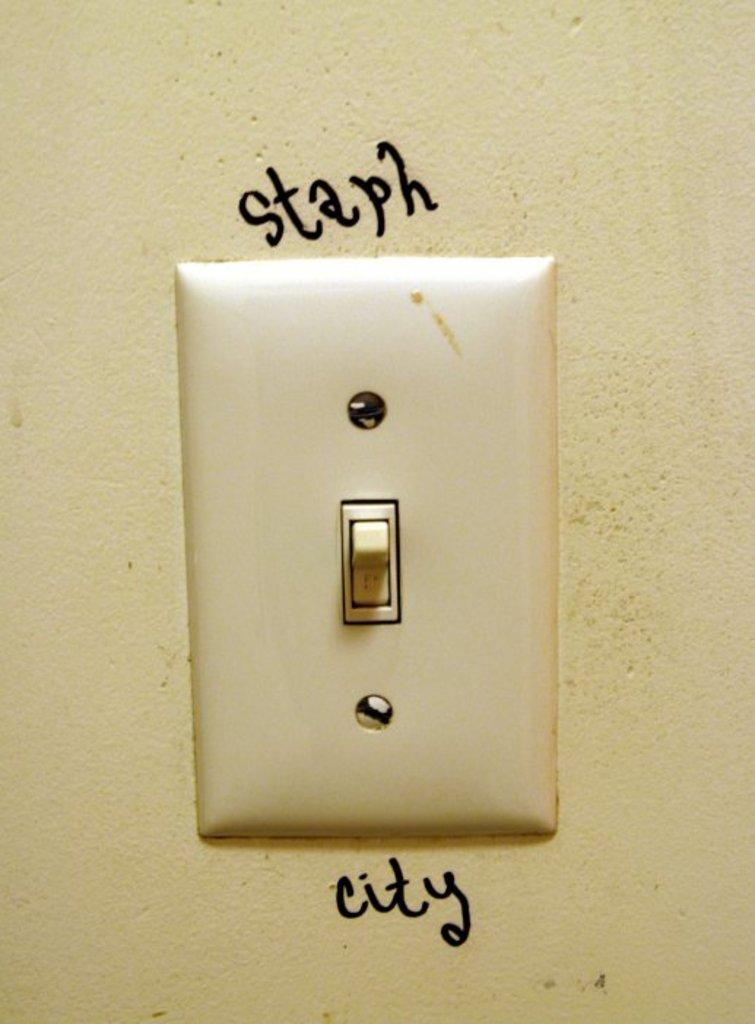Have you ever been to staph city?
Give a very brief answer. Answering does not require reading text in the image. What word is written below the light switch?
Provide a succinct answer. City. 